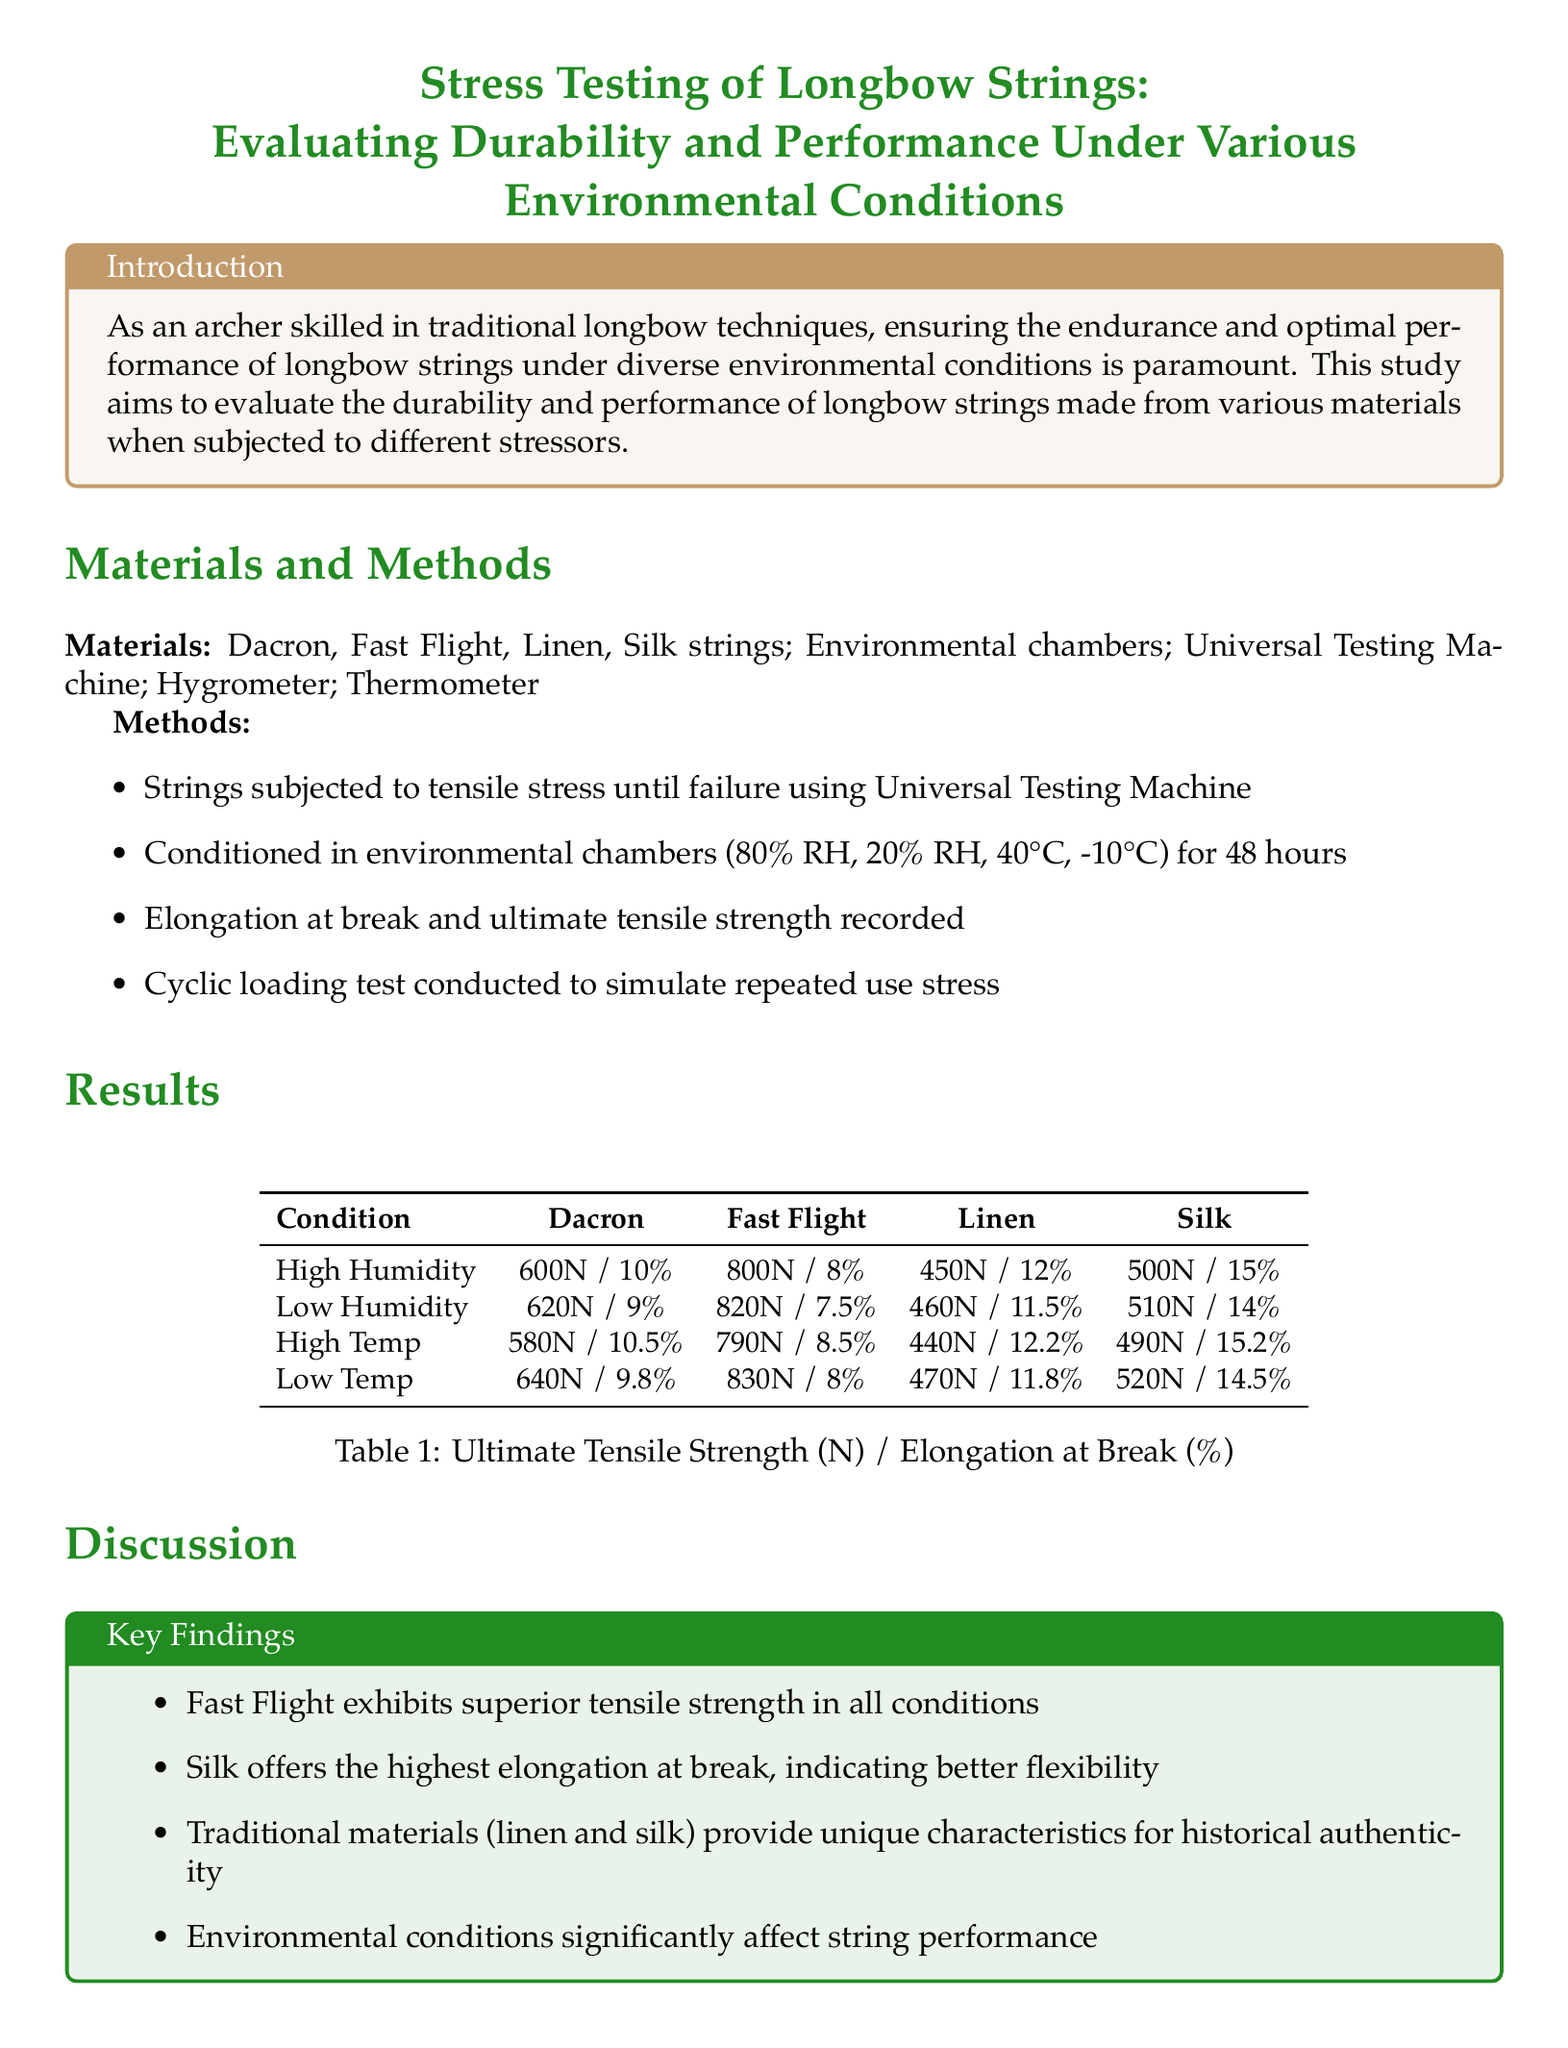What is the main objective of the study? The study aims to evaluate the durability and performance of longbow strings made from various materials when subjected to different stressors.
Answer: To evaluate durability and performance Which string exhibits the highest tensile strength under low humidity? The table indicates that Fast Flight has the highest tensile strength in low humidity conditions.
Answer: Fast Flight What is the elongation at break for Silk strings in high temperature conditions? The results table shows that Silk has an elongation at break of 15.2% in high temperature conditions.
Answer: 15.2% What material shows the best performance in high humidity? The findings highlight that Fast Flight strings exhibit superior performance across all tested conditions, including high humidity.
Answer: Fast Flight How many environmental conditions were tested in the study? Information from the methods section indicates that four environmental conditions were tested.
Answer: Four 